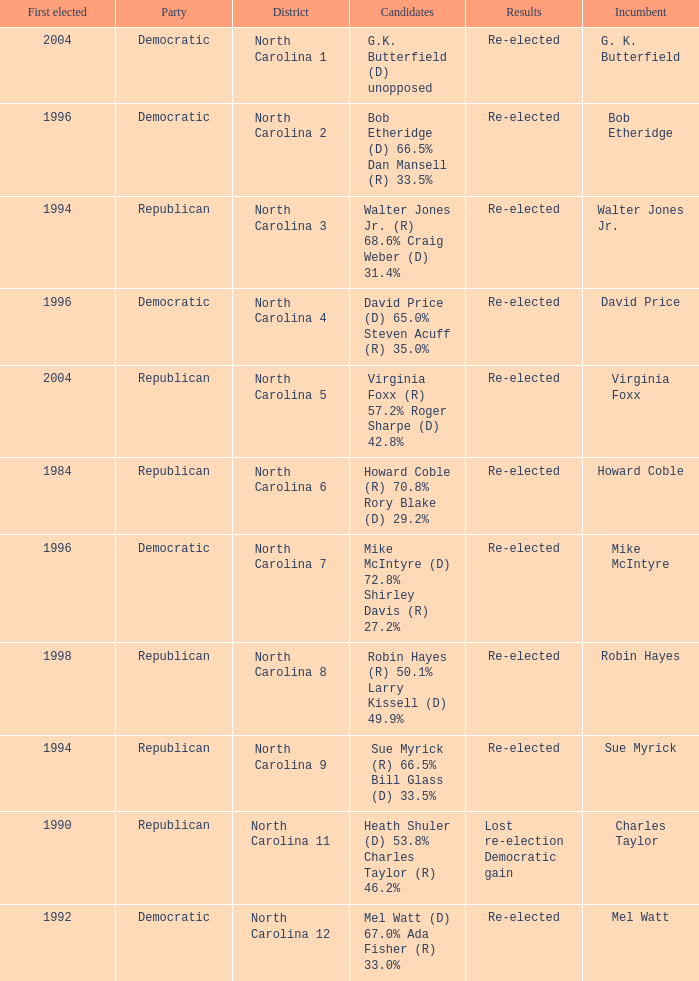How many times did Robin Hayes run? 1.0. 